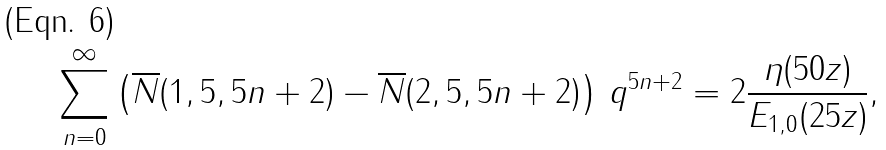<formula> <loc_0><loc_0><loc_500><loc_500>\sum _ { n = 0 } ^ { \infty } \left ( \overline { N } ( 1 , 5 , 5 n + 2 ) - \overline { N } ( 2 , 5 , 5 n + 2 ) \right ) \, q ^ { 5 n + 2 } = 2 \frac { \eta ( 5 0 z ) } { E _ { 1 , 0 } ( 2 5 z ) } ,</formula> 